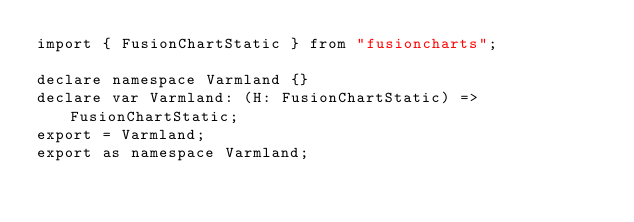Convert code to text. <code><loc_0><loc_0><loc_500><loc_500><_TypeScript_>import { FusionChartStatic } from "fusioncharts";

declare namespace Varmland {}
declare var Varmland: (H: FusionChartStatic) => FusionChartStatic;
export = Varmland;
export as namespace Varmland;

</code> 